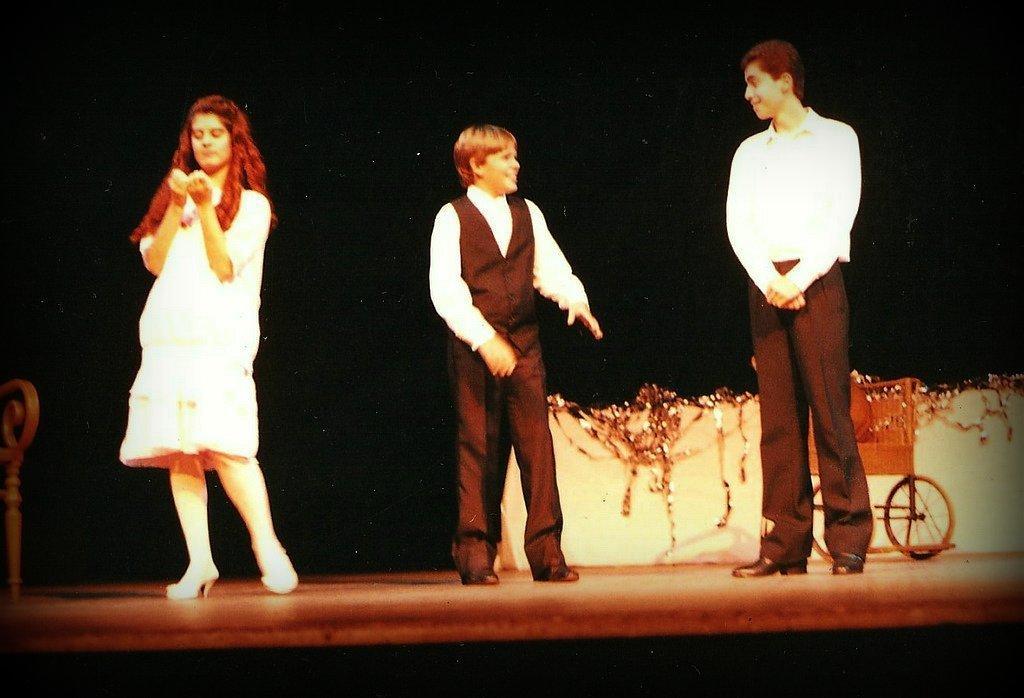How would you summarize this image in a sentence or two? In this image I can see on the right side there is a wheelchair, in the middle two men are standing, they are wearing trousers, shirts. On the left side there is a girl, she is wearing the dress. 